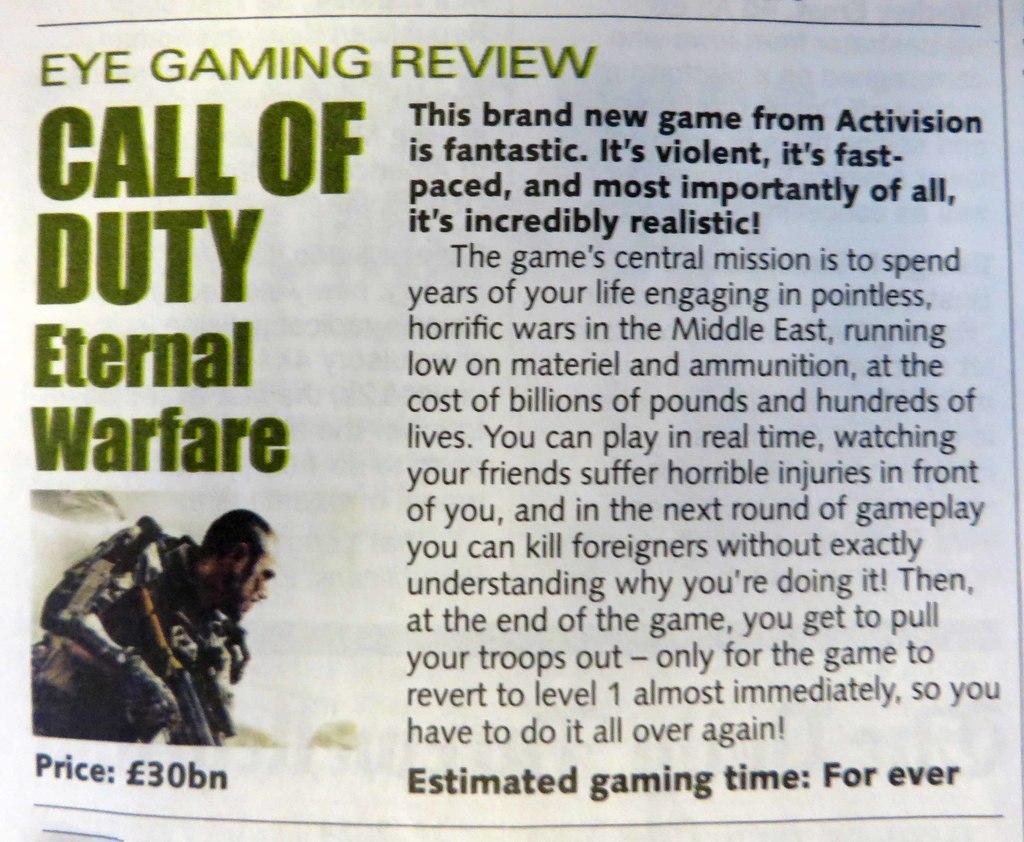<image>
Describe the image concisely. A game review for Call of Duty Eternal Warfare. 